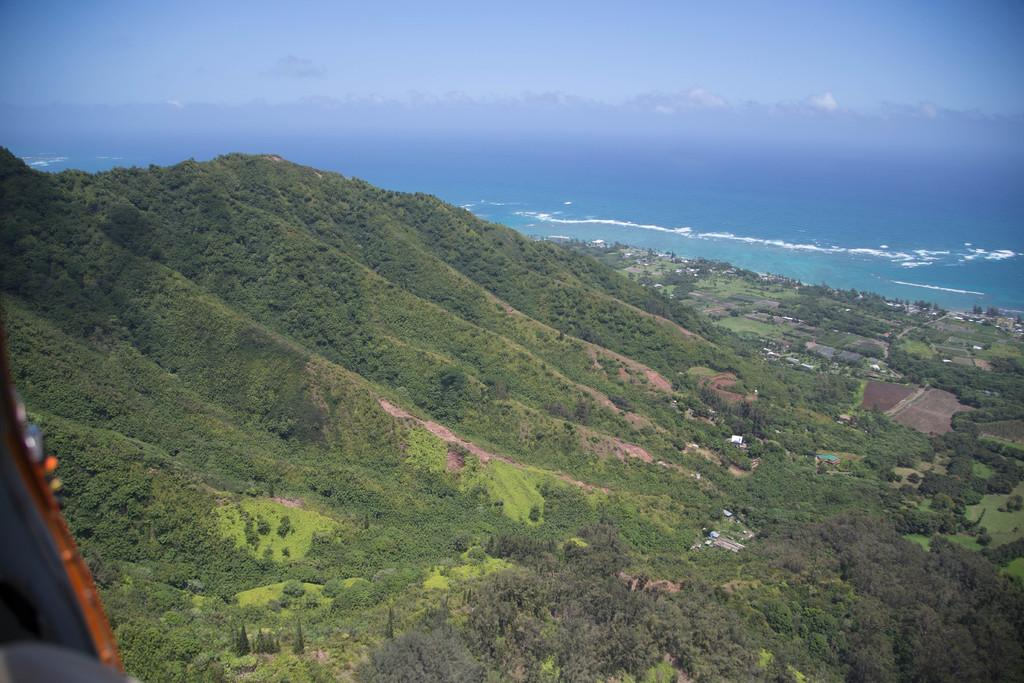What type of vegetation is present on the ground in the image? There are trees and plants on the ground in the image. What can be seen in the distance behind the vegetation? There is an ocean in the background of the image. What is visible in the sky in the image? There are clouds in the sky in the image. What operation is being performed on the trees in the image? There is no operation being performed on the trees in the image; they are simply standing on the ground. 